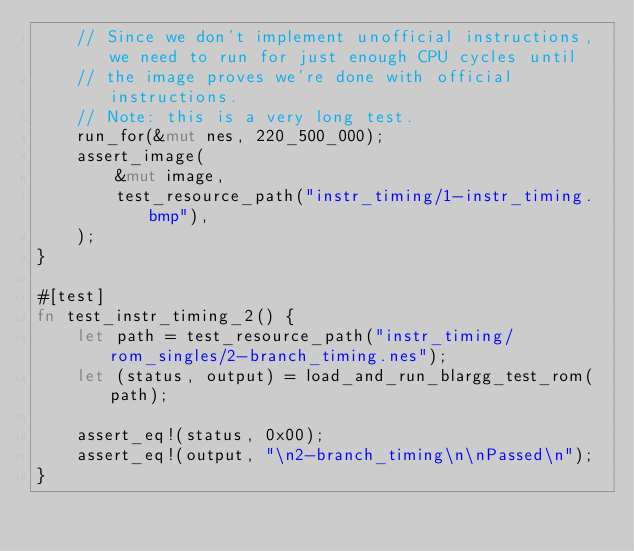Convert code to text. <code><loc_0><loc_0><loc_500><loc_500><_Rust_>    // Since we don't implement unofficial instructions, we need to run for just enough CPU cycles until
    // the image proves we're done with official instructions.
    // Note: this is a very long test.
    run_for(&mut nes, 220_500_000);
    assert_image(
        &mut image,
        test_resource_path("instr_timing/1-instr_timing.bmp"),
    );
}

#[test]
fn test_instr_timing_2() {
    let path = test_resource_path("instr_timing/rom_singles/2-branch_timing.nes");
    let (status, output) = load_and_run_blargg_test_rom(path);

    assert_eq!(status, 0x00);
    assert_eq!(output, "\n2-branch_timing\n\nPassed\n");
}
</code> 